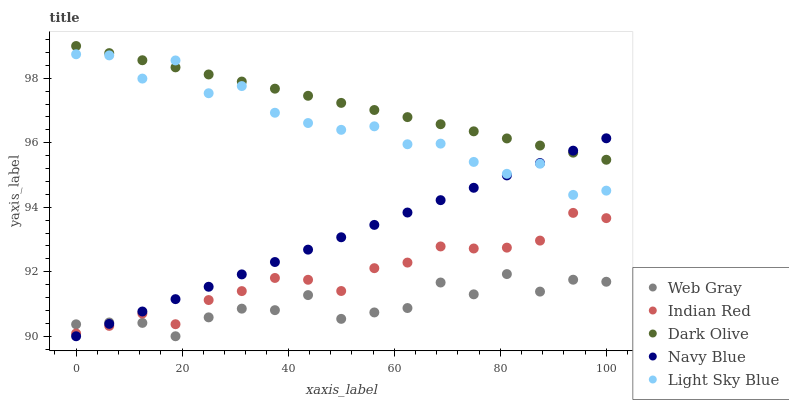Does Web Gray have the minimum area under the curve?
Answer yes or no. Yes. Does Dark Olive have the maximum area under the curve?
Answer yes or no. Yes. Does Navy Blue have the minimum area under the curve?
Answer yes or no. No. Does Navy Blue have the maximum area under the curve?
Answer yes or no. No. Is Dark Olive the smoothest?
Answer yes or no. Yes. Is Light Sky Blue the roughest?
Answer yes or no. Yes. Is Web Gray the smoothest?
Answer yes or no. No. Is Web Gray the roughest?
Answer yes or no. No. Does Navy Blue have the lowest value?
Answer yes or no. Yes. Does Indian Red have the lowest value?
Answer yes or no. No. Does Dark Olive have the highest value?
Answer yes or no. Yes. Does Navy Blue have the highest value?
Answer yes or no. No. Is Web Gray less than Dark Olive?
Answer yes or no. Yes. Is Light Sky Blue greater than Web Gray?
Answer yes or no. Yes. Does Indian Red intersect Navy Blue?
Answer yes or no. Yes. Is Indian Red less than Navy Blue?
Answer yes or no. No. Is Indian Red greater than Navy Blue?
Answer yes or no. No. Does Web Gray intersect Dark Olive?
Answer yes or no. No. 